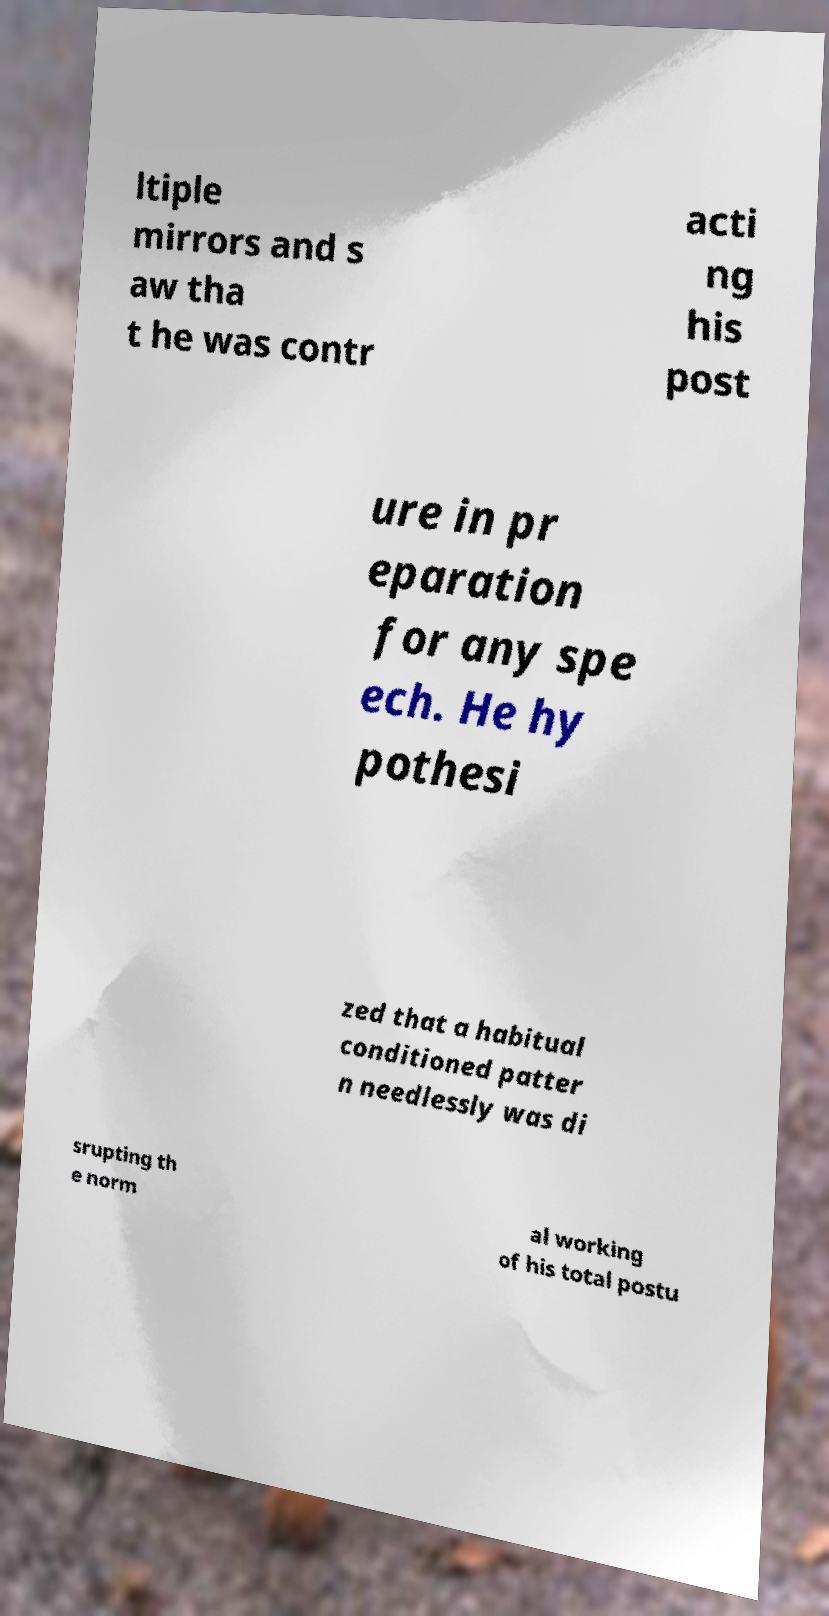For documentation purposes, I need the text within this image transcribed. Could you provide that? ltiple mirrors and s aw tha t he was contr acti ng his post ure in pr eparation for any spe ech. He hy pothesi zed that a habitual conditioned patter n needlessly was di srupting th e norm al working of his total postu 